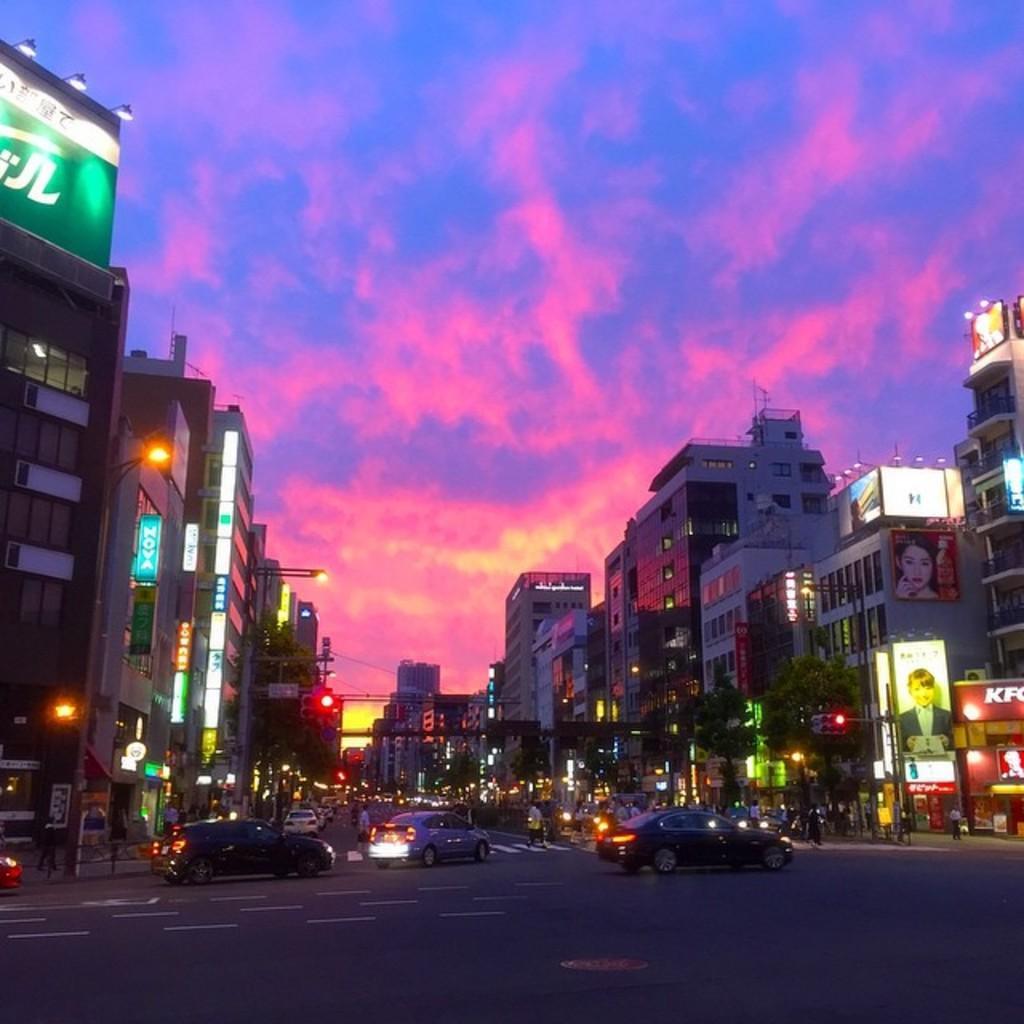Could you give a brief overview of what you see in this image? At the bottom of this image, there is a road, on which there are vehicles and persons. On both sides of this road, there are buildings having hoardings, there are lights attached to the poles and there are trees. In the background, there are clouds in the sky. 